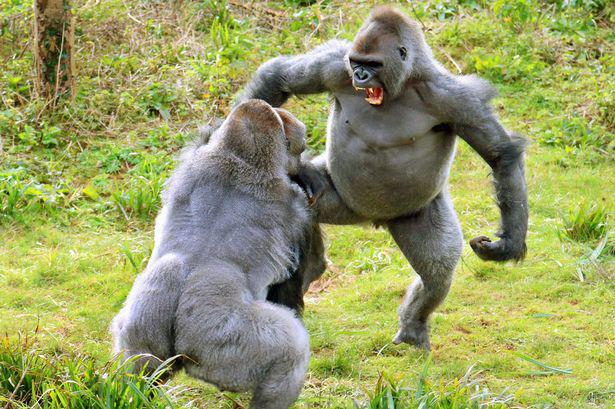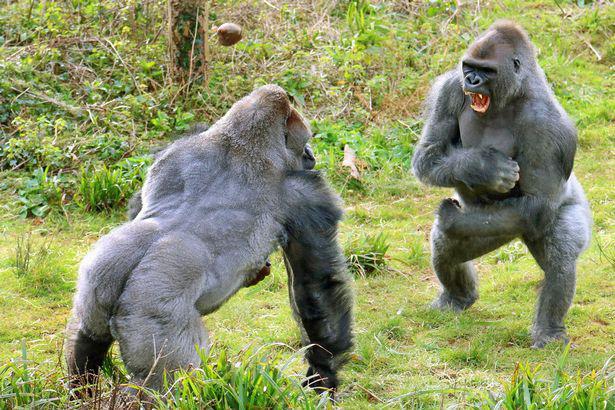The first image is the image on the left, the second image is the image on the right. Analyze the images presented: Is the assertion "In each image, two male gorillas stand facing each other, with one gorilla baring its fangs with wide-open mouth." valid? Answer yes or no. Yes. The first image is the image on the left, the second image is the image on the right. For the images shown, is this caption "Two animals are standing up in each of the images." true? Answer yes or no. Yes. 